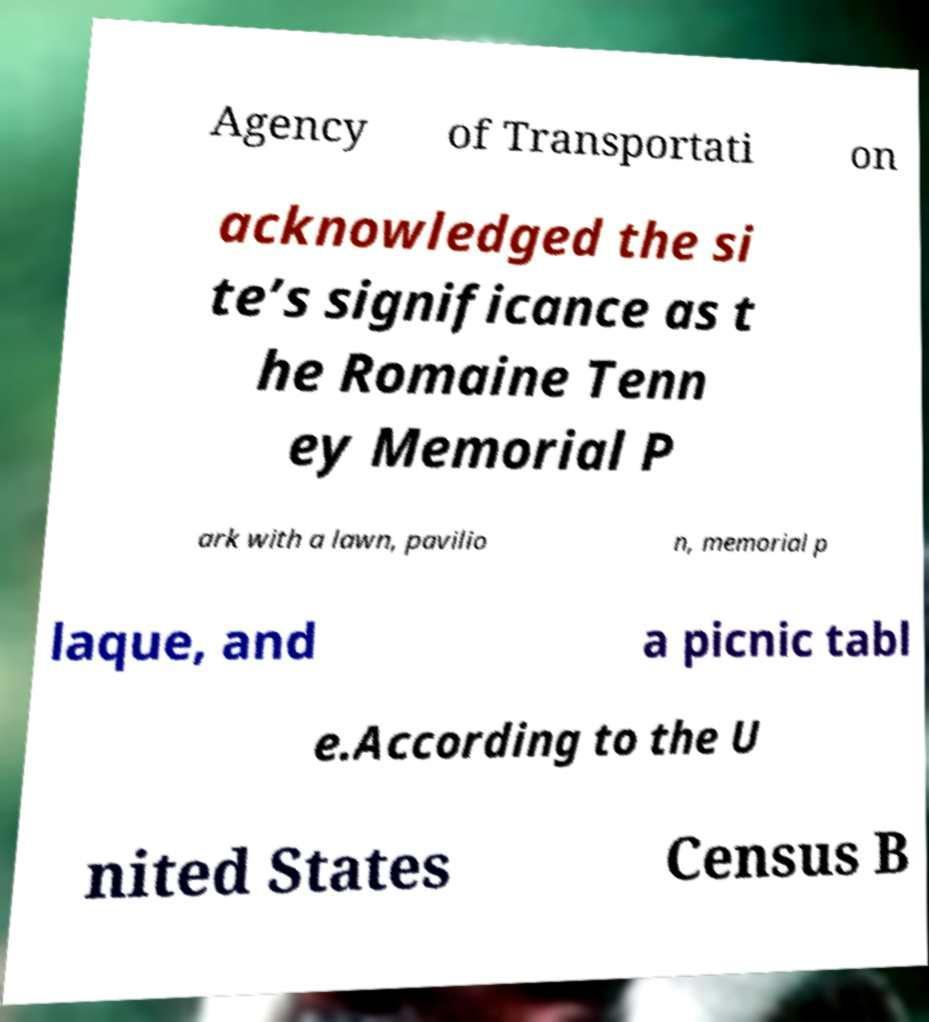I need the written content from this picture converted into text. Can you do that? Agency of Transportati on acknowledged the si te’s significance as t he Romaine Tenn ey Memorial P ark with a lawn, pavilio n, memorial p laque, and a picnic tabl e.According to the U nited States Census B 